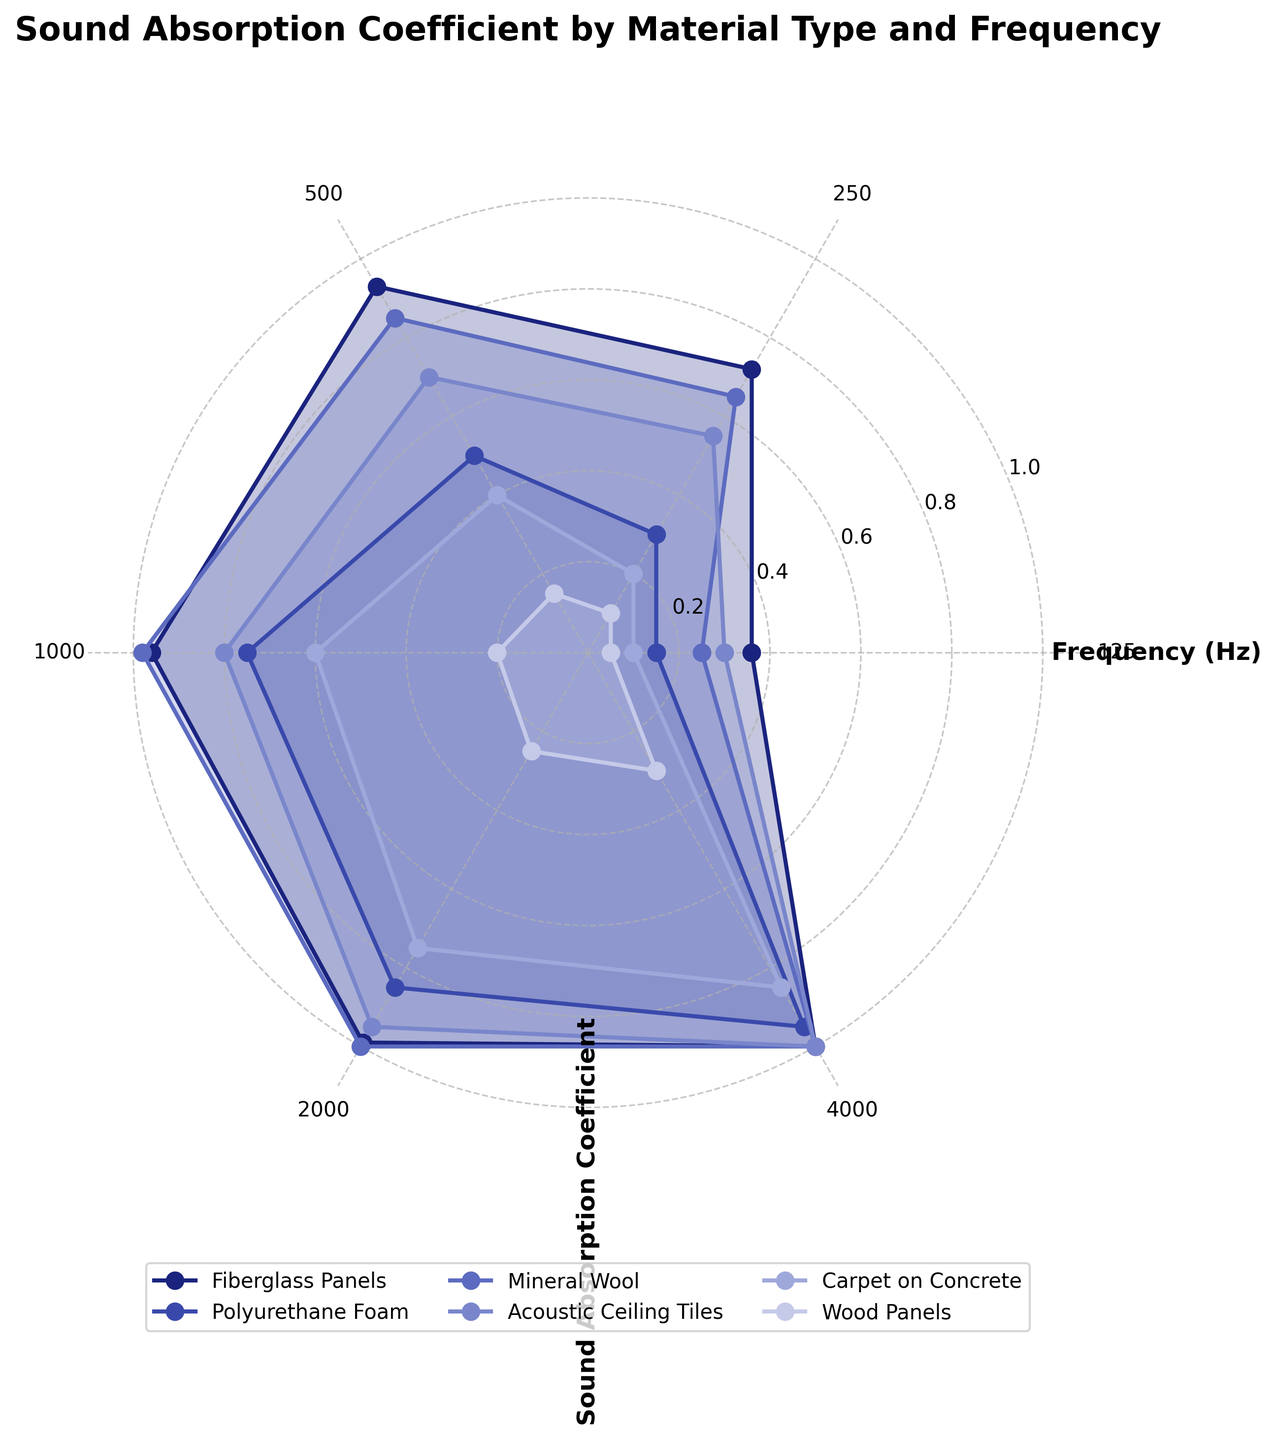What materials are represented in the figure? The materials are listed in the legend of the rose chart. They are Fiberglass Panels, Polyurethane Foam, Mineral Wool, Acoustic Ceiling Tiles, Carpet on Concrete, and Wood Panels.
Answer: Fiberglass Panels, Polyurethane Foam, Mineral Wool, Acoustic Ceiling Tiles, Carpet on Concrete, and Wood Panels At which frequency do Fiberglass Panels have the highest sound absorption coefficient? By observing the plot for Fiberglass Panels, the highest sound absorption coefficient is at 4000 Hz.
Answer: 4000 Hz Which material has the lowest sound absorption coefficient at 125 Hz? The sound absorption coefficients at 125 Hz for all materials are compared. Wood Panels have the lowest coefficient of 0.05.
Answer: Wood Panels How does the sound absorption coefficient for Mineral Wool change as the frequency increases from 125 Hz to 4000 Hz? Examining the Mineral Wool line in the rose chart, the sound absorption coefficient increases from 0.25 to 1.00 as frequency rises from 125 Hz to 4000 Hz.
Answer: Increases What is the average sound absorption coefficient for Polyurethane Foam across all frequencies? Adding all sound absorption coefficients for Polyurethane Foam (0.15, 0.30, 0.50, 0.75, 0.85, 0.95) and dividing by the number of frequencies (6) results in the average. (0.15+0.30+0.50+0.75+0.85+0.95) / 6 = 0.58
Answer: 0.58 Which material has the highest average sound absorption coefficient across all frequencies? Calculate the average sound absorption coefficient for each material, then compare. Fiberglass Panels average (0.36+0.72+0.93+0.96+0.99+1.00)/6 = 0.83, Mineral Wool average (0.25+0.65+0.85+0.98+1.00+1.00)/6 = 0.79, Acoustic Ceiling Tiles average (0.30+0.55+0.70+0.80+0.95+1.00)/6 = 0.72, Polyurethane Foam average = 0.58, Carpet on Concrete average (0.10+0.20+0.40+0.60+0.75+0.85)/6 = 0.48, Wood Panels average (0.05+0.10+0.15+0.20+0.25+0.30)/6 = 0.18. Therefore, Fiberglass Panels have the highest average.
Answer: Fiberglass Panels Between Carpet on Concrete and Acoustic Ceiling Tiles, which material has a higher sound absorption coefficient at 2000 Hz? Looking at 2000 Hz on the rose chart, the coefficient for Acoustic Ceiling Tiles is higher than that of Carpet on Concrete (0.95 vs. 0.75).
Answer: Acoustic Ceiling Tiles Do any materials reach a sound absorption coefficient of 1.0? If so, which ones? Observing the rose chart, Fiberglass Panels at 4000 Hz, Mineral Wool at 2000 Hz and 4000 Hz, and Acoustic Ceiling Tiles at 4000 Hz all reach a coefficient of 1.0.
Answer: Fiberglass Panels, Mineral Wool, Acoustic Ceiling Tiles How does the shape of the plot for Wood Panels compare to that for Fiberglass Panels? The plot for Wood Panels has a much smaller radii spread, indicating lower coefficients, and a less uniform polygon, while Fiberglass Panels have a larger radii spread and a more uniform, nearly filled shape, indicating higher coefficients and more consistent absorption across frequencies.
Answer: Wood Panels have smaller radii and are less uniform; Fiberglass Panels have larger radii and are more uniform 